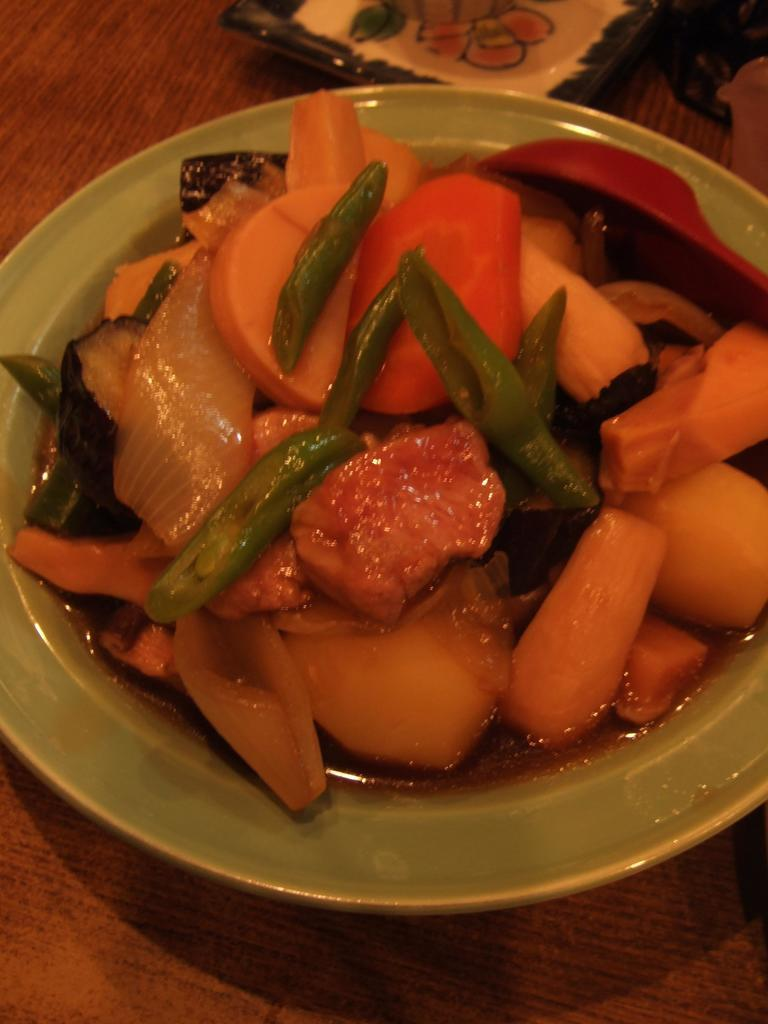What type of furniture is present in the image? There is a table in the image. What is placed on the table in the image? There is a plate on the table. What is on the plate that is visible in the image? There is a food item on the plate. How many babies are present in the image? There are no babies present in the image. Can you describe the type of kiss that is being exchanged in the image? There is no kiss present in the image. 